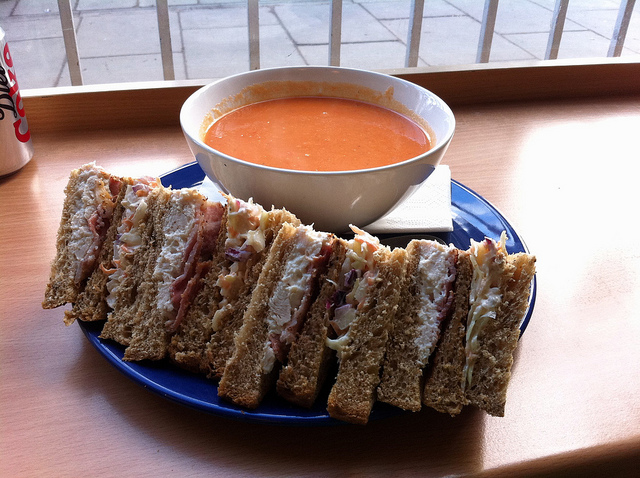What kind of sandwich is shown in the image? The sandwich in the image appears to be a classic club sandwich, which typically contains turkey, bacon, lettuce, tomato, and mayonnaise. 